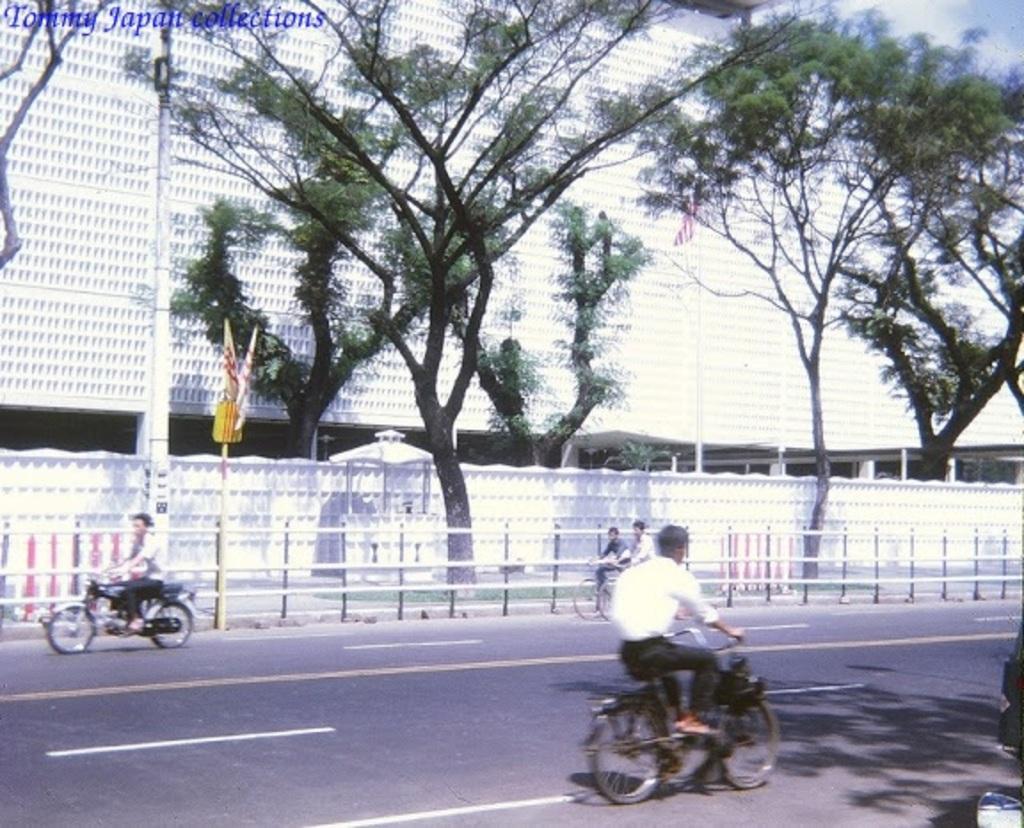Describe this image in one or two sentences. On the road there are three men riding a bicycle and one man riding a motor cycle. There is a footpath with trees on it. In the background there is a building which is in white color. 